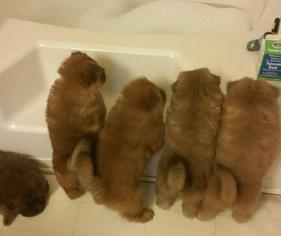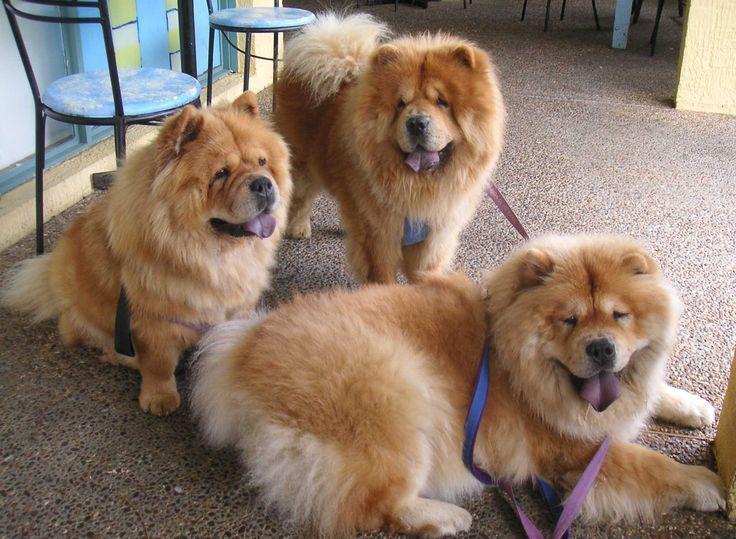The first image is the image on the left, the second image is the image on the right. Assess this claim about the two images: "There is a dog with a stuffed animal in the image on the left.". Correct or not? Answer yes or no. No. 